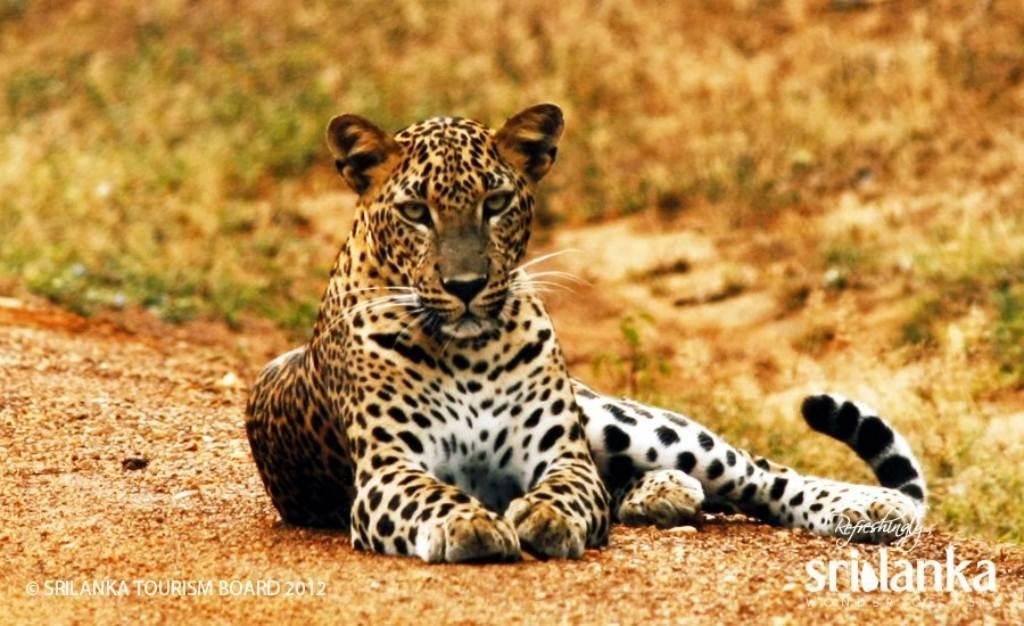What animal is in the image? There is a tiger in the image. What is the tiger doing in the image? The tiger is sitting on a surface. Can you describe the background of the image? The background of the image is blurry. What is present at the bottom of the image? There is text at the bottom of the image. What hobbies does the tiger have, as depicted in the image? The image does not provide information about the tiger's hobbies. 